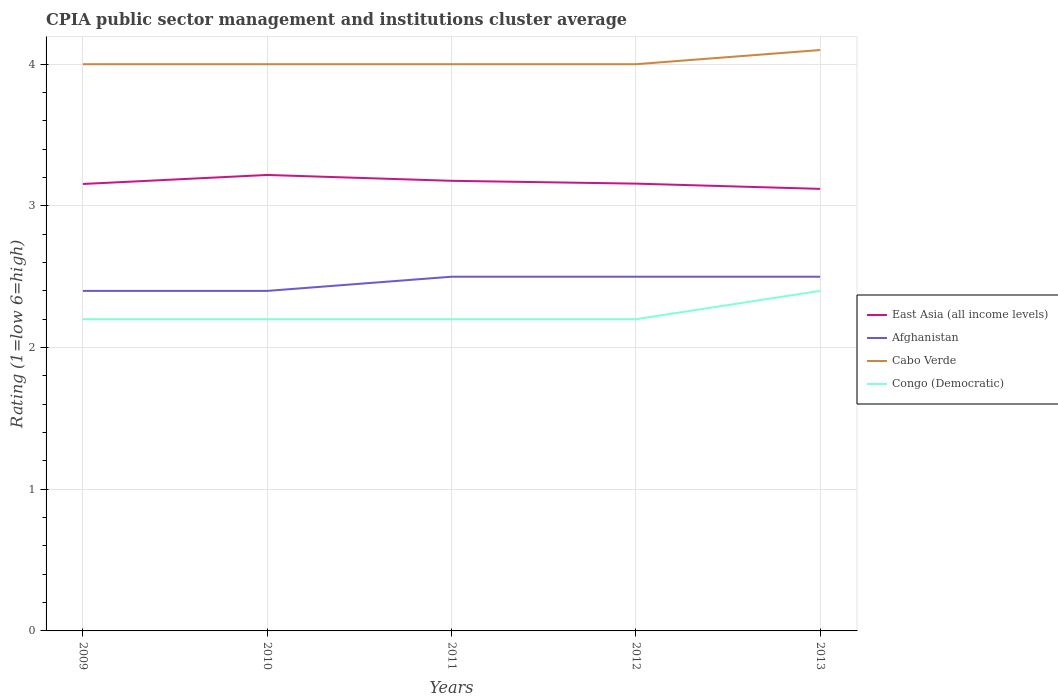Does the line corresponding to East Asia (all income levels) intersect with the line corresponding to Afghanistan?
Provide a short and direct response. No. Is the number of lines equal to the number of legend labels?
Keep it short and to the point. Yes. Across all years, what is the maximum CPIA rating in Afghanistan?
Ensure brevity in your answer.  2.4. In which year was the CPIA rating in East Asia (all income levels) maximum?
Your answer should be compact. 2013. What is the total CPIA rating in East Asia (all income levels) in the graph?
Keep it short and to the point. 0.03. What is the difference between the highest and the second highest CPIA rating in Afghanistan?
Keep it short and to the point. 0.1. Is the CPIA rating in Congo (Democratic) strictly greater than the CPIA rating in Cabo Verde over the years?
Give a very brief answer. Yes. How many years are there in the graph?
Make the answer very short. 5. What is the difference between two consecutive major ticks on the Y-axis?
Your answer should be very brief. 1. Are the values on the major ticks of Y-axis written in scientific E-notation?
Your response must be concise. No. Does the graph contain any zero values?
Your answer should be very brief. No. Does the graph contain grids?
Offer a very short reply. Yes. Where does the legend appear in the graph?
Give a very brief answer. Center right. How many legend labels are there?
Your answer should be compact. 4. How are the legend labels stacked?
Provide a succinct answer. Vertical. What is the title of the graph?
Offer a very short reply. CPIA public sector management and institutions cluster average. Does "High income: OECD" appear as one of the legend labels in the graph?
Make the answer very short. No. What is the Rating (1=low 6=high) in East Asia (all income levels) in 2009?
Your response must be concise. 3.15. What is the Rating (1=low 6=high) in Cabo Verde in 2009?
Your response must be concise. 4. What is the Rating (1=low 6=high) of East Asia (all income levels) in 2010?
Provide a succinct answer. 3.22. What is the Rating (1=low 6=high) of Afghanistan in 2010?
Make the answer very short. 2.4. What is the Rating (1=low 6=high) in East Asia (all income levels) in 2011?
Keep it short and to the point. 3.18. What is the Rating (1=low 6=high) in Cabo Verde in 2011?
Your response must be concise. 4. What is the Rating (1=low 6=high) in East Asia (all income levels) in 2012?
Provide a succinct answer. 3.16. What is the Rating (1=low 6=high) of Cabo Verde in 2012?
Offer a terse response. 4. What is the Rating (1=low 6=high) of East Asia (all income levels) in 2013?
Your response must be concise. 3.12. What is the Rating (1=low 6=high) in Afghanistan in 2013?
Make the answer very short. 2.5. What is the Rating (1=low 6=high) in Cabo Verde in 2013?
Make the answer very short. 4.1. Across all years, what is the maximum Rating (1=low 6=high) in East Asia (all income levels)?
Your answer should be very brief. 3.22. Across all years, what is the maximum Rating (1=low 6=high) in Cabo Verde?
Your response must be concise. 4.1. Across all years, what is the maximum Rating (1=low 6=high) of Congo (Democratic)?
Your response must be concise. 2.4. Across all years, what is the minimum Rating (1=low 6=high) of East Asia (all income levels)?
Provide a short and direct response. 3.12. Across all years, what is the minimum Rating (1=low 6=high) in Afghanistan?
Make the answer very short. 2.4. Across all years, what is the minimum Rating (1=low 6=high) of Congo (Democratic)?
Your answer should be very brief. 2.2. What is the total Rating (1=low 6=high) in East Asia (all income levels) in the graph?
Provide a succinct answer. 15.83. What is the total Rating (1=low 6=high) of Afghanistan in the graph?
Keep it short and to the point. 12.3. What is the total Rating (1=low 6=high) of Cabo Verde in the graph?
Give a very brief answer. 20.1. What is the difference between the Rating (1=low 6=high) in East Asia (all income levels) in 2009 and that in 2010?
Provide a short and direct response. -0.06. What is the difference between the Rating (1=low 6=high) of Cabo Verde in 2009 and that in 2010?
Provide a succinct answer. 0. What is the difference between the Rating (1=low 6=high) of East Asia (all income levels) in 2009 and that in 2011?
Your answer should be very brief. -0.02. What is the difference between the Rating (1=low 6=high) in Afghanistan in 2009 and that in 2011?
Make the answer very short. -0.1. What is the difference between the Rating (1=low 6=high) in East Asia (all income levels) in 2009 and that in 2012?
Ensure brevity in your answer.  -0. What is the difference between the Rating (1=low 6=high) of Afghanistan in 2009 and that in 2012?
Your answer should be compact. -0.1. What is the difference between the Rating (1=low 6=high) in Congo (Democratic) in 2009 and that in 2012?
Offer a very short reply. 0. What is the difference between the Rating (1=low 6=high) in East Asia (all income levels) in 2009 and that in 2013?
Offer a terse response. 0.03. What is the difference between the Rating (1=low 6=high) of Afghanistan in 2009 and that in 2013?
Make the answer very short. -0.1. What is the difference between the Rating (1=low 6=high) of Cabo Verde in 2009 and that in 2013?
Your answer should be compact. -0.1. What is the difference between the Rating (1=low 6=high) of East Asia (all income levels) in 2010 and that in 2011?
Offer a very short reply. 0.04. What is the difference between the Rating (1=low 6=high) of Afghanistan in 2010 and that in 2011?
Provide a succinct answer. -0.1. What is the difference between the Rating (1=low 6=high) of Cabo Verde in 2010 and that in 2011?
Offer a terse response. 0. What is the difference between the Rating (1=low 6=high) of Congo (Democratic) in 2010 and that in 2011?
Provide a short and direct response. 0. What is the difference between the Rating (1=low 6=high) of East Asia (all income levels) in 2010 and that in 2012?
Keep it short and to the point. 0.06. What is the difference between the Rating (1=low 6=high) in Afghanistan in 2010 and that in 2012?
Offer a terse response. -0.1. What is the difference between the Rating (1=low 6=high) of Congo (Democratic) in 2010 and that in 2012?
Provide a succinct answer. 0. What is the difference between the Rating (1=low 6=high) of East Asia (all income levels) in 2010 and that in 2013?
Offer a terse response. 0.1. What is the difference between the Rating (1=low 6=high) in Afghanistan in 2010 and that in 2013?
Make the answer very short. -0.1. What is the difference between the Rating (1=low 6=high) in Congo (Democratic) in 2010 and that in 2013?
Ensure brevity in your answer.  -0.2. What is the difference between the Rating (1=low 6=high) in East Asia (all income levels) in 2011 and that in 2012?
Your response must be concise. 0.02. What is the difference between the Rating (1=low 6=high) of Afghanistan in 2011 and that in 2012?
Give a very brief answer. 0. What is the difference between the Rating (1=low 6=high) in Cabo Verde in 2011 and that in 2012?
Offer a terse response. 0. What is the difference between the Rating (1=low 6=high) in Congo (Democratic) in 2011 and that in 2012?
Your response must be concise. 0. What is the difference between the Rating (1=low 6=high) in East Asia (all income levels) in 2011 and that in 2013?
Offer a very short reply. 0.06. What is the difference between the Rating (1=low 6=high) in Afghanistan in 2011 and that in 2013?
Offer a terse response. 0. What is the difference between the Rating (1=low 6=high) in Cabo Verde in 2011 and that in 2013?
Provide a short and direct response. -0.1. What is the difference between the Rating (1=low 6=high) in East Asia (all income levels) in 2012 and that in 2013?
Offer a terse response. 0.04. What is the difference between the Rating (1=low 6=high) in Afghanistan in 2012 and that in 2013?
Provide a short and direct response. 0. What is the difference between the Rating (1=low 6=high) in East Asia (all income levels) in 2009 and the Rating (1=low 6=high) in Afghanistan in 2010?
Keep it short and to the point. 0.75. What is the difference between the Rating (1=low 6=high) of East Asia (all income levels) in 2009 and the Rating (1=low 6=high) of Cabo Verde in 2010?
Keep it short and to the point. -0.85. What is the difference between the Rating (1=low 6=high) in East Asia (all income levels) in 2009 and the Rating (1=low 6=high) in Congo (Democratic) in 2010?
Your answer should be compact. 0.95. What is the difference between the Rating (1=low 6=high) in Afghanistan in 2009 and the Rating (1=low 6=high) in Congo (Democratic) in 2010?
Keep it short and to the point. 0.2. What is the difference between the Rating (1=low 6=high) of East Asia (all income levels) in 2009 and the Rating (1=low 6=high) of Afghanistan in 2011?
Your answer should be very brief. 0.65. What is the difference between the Rating (1=low 6=high) of East Asia (all income levels) in 2009 and the Rating (1=low 6=high) of Cabo Verde in 2011?
Offer a terse response. -0.85. What is the difference between the Rating (1=low 6=high) in East Asia (all income levels) in 2009 and the Rating (1=low 6=high) in Congo (Democratic) in 2011?
Ensure brevity in your answer.  0.95. What is the difference between the Rating (1=low 6=high) in Afghanistan in 2009 and the Rating (1=low 6=high) in Cabo Verde in 2011?
Offer a terse response. -1.6. What is the difference between the Rating (1=low 6=high) of Cabo Verde in 2009 and the Rating (1=low 6=high) of Congo (Democratic) in 2011?
Provide a succinct answer. 1.8. What is the difference between the Rating (1=low 6=high) of East Asia (all income levels) in 2009 and the Rating (1=low 6=high) of Afghanistan in 2012?
Offer a terse response. 0.65. What is the difference between the Rating (1=low 6=high) of East Asia (all income levels) in 2009 and the Rating (1=low 6=high) of Cabo Verde in 2012?
Provide a short and direct response. -0.85. What is the difference between the Rating (1=low 6=high) in East Asia (all income levels) in 2009 and the Rating (1=low 6=high) in Congo (Democratic) in 2012?
Your response must be concise. 0.95. What is the difference between the Rating (1=low 6=high) in Afghanistan in 2009 and the Rating (1=low 6=high) in Cabo Verde in 2012?
Your answer should be compact. -1.6. What is the difference between the Rating (1=low 6=high) of Cabo Verde in 2009 and the Rating (1=low 6=high) of Congo (Democratic) in 2012?
Keep it short and to the point. 1.8. What is the difference between the Rating (1=low 6=high) in East Asia (all income levels) in 2009 and the Rating (1=low 6=high) in Afghanistan in 2013?
Your answer should be compact. 0.65. What is the difference between the Rating (1=low 6=high) of East Asia (all income levels) in 2009 and the Rating (1=low 6=high) of Cabo Verde in 2013?
Your response must be concise. -0.95. What is the difference between the Rating (1=low 6=high) of East Asia (all income levels) in 2009 and the Rating (1=low 6=high) of Congo (Democratic) in 2013?
Provide a succinct answer. 0.75. What is the difference between the Rating (1=low 6=high) in Afghanistan in 2009 and the Rating (1=low 6=high) in Cabo Verde in 2013?
Offer a very short reply. -1.7. What is the difference between the Rating (1=low 6=high) in Cabo Verde in 2009 and the Rating (1=low 6=high) in Congo (Democratic) in 2013?
Make the answer very short. 1.6. What is the difference between the Rating (1=low 6=high) in East Asia (all income levels) in 2010 and the Rating (1=low 6=high) in Afghanistan in 2011?
Your answer should be very brief. 0.72. What is the difference between the Rating (1=low 6=high) in East Asia (all income levels) in 2010 and the Rating (1=low 6=high) in Cabo Verde in 2011?
Your answer should be compact. -0.78. What is the difference between the Rating (1=low 6=high) in East Asia (all income levels) in 2010 and the Rating (1=low 6=high) in Congo (Democratic) in 2011?
Offer a terse response. 1.02. What is the difference between the Rating (1=low 6=high) in Afghanistan in 2010 and the Rating (1=low 6=high) in Cabo Verde in 2011?
Your answer should be compact. -1.6. What is the difference between the Rating (1=low 6=high) in East Asia (all income levels) in 2010 and the Rating (1=low 6=high) in Afghanistan in 2012?
Make the answer very short. 0.72. What is the difference between the Rating (1=low 6=high) in East Asia (all income levels) in 2010 and the Rating (1=low 6=high) in Cabo Verde in 2012?
Offer a terse response. -0.78. What is the difference between the Rating (1=low 6=high) of East Asia (all income levels) in 2010 and the Rating (1=low 6=high) of Congo (Democratic) in 2012?
Provide a succinct answer. 1.02. What is the difference between the Rating (1=low 6=high) of Afghanistan in 2010 and the Rating (1=low 6=high) of Cabo Verde in 2012?
Your answer should be very brief. -1.6. What is the difference between the Rating (1=low 6=high) of East Asia (all income levels) in 2010 and the Rating (1=low 6=high) of Afghanistan in 2013?
Offer a terse response. 0.72. What is the difference between the Rating (1=low 6=high) in East Asia (all income levels) in 2010 and the Rating (1=low 6=high) in Cabo Verde in 2013?
Ensure brevity in your answer.  -0.88. What is the difference between the Rating (1=low 6=high) of East Asia (all income levels) in 2010 and the Rating (1=low 6=high) of Congo (Democratic) in 2013?
Provide a short and direct response. 0.82. What is the difference between the Rating (1=low 6=high) of Cabo Verde in 2010 and the Rating (1=low 6=high) of Congo (Democratic) in 2013?
Provide a short and direct response. 1.6. What is the difference between the Rating (1=low 6=high) of East Asia (all income levels) in 2011 and the Rating (1=low 6=high) of Afghanistan in 2012?
Give a very brief answer. 0.68. What is the difference between the Rating (1=low 6=high) of East Asia (all income levels) in 2011 and the Rating (1=low 6=high) of Cabo Verde in 2012?
Provide a short and direct response. -0.82. What is the difference between the Rating (1=low 6=high) of East Asia (all income levels) in 2011 and the Rating (1=low 6=high) of Congo (Democratic) in 2012?
Offer a terse response. 0.98. What is the difference between the Rating (1=low 6=high) in Afghanistan in 2011 and the Rating (1=low 6=high) in Cabo Verde in 2012?
Provide a short and direct response. -1.5. What is the difference between the Rating (1=low 6=high) in Cabo Verde in 2011 and the Rating (1=low 6=high) in Congo (Democratic) in 2012?
Offer a terse response. 1.8. What is the difference between the Rating (1=low 6=high) in East Asia (all income levels) in 2011 and the Rating (1=low 6=high) in Afghanistan in 2013?
Your answer should be very brief. 0.68. What is the difference between the Rating (1=low 6=high) of East Asia (all income levels) in 2011 and the Rating (1=low 6=high) of Cabo Verde in 2013?
Make the answer very short. -0.92. What is the difference between the Rating (1=low 6=high) of East Asia (all income levels) in 2011 and the Rating (1=low 6=high) of Congo (Democratic) in 2013?
Give a very brief answer. 0.78. What is the difference between the Rating (1=low 6=high) of Afghanistan in 2011 and the Rating (1=low 6=high) of Congo (Democratic) in 2013?
Your answer should be compact. 0.1. What is the difference between the Rating (1=low 6=high) of Cabo Verde in 2011 and the Rating (1=low 6=high) of Congo (Democratic) in 2013?
Offer a very short reply. 1.6. What is the difference between the Rating (1=low 6=high) of East Asia (all income levels) in 2012 and the Rating (1=low 6=high) of Afghanistan in 2013?
Your answer should be very brief. 0.66. What is the difference between the Rating (1=low 6=high) of East Asia (all income levels) in 2012 and the Rating (1=low 6=high) of Cabo Verde in 2013?
Your answer should be very brief. -0.94. What is the difference between the Rating (1=low 6=high) in East Asia (all income levels) in 2012 and the Rating (1=low 6=high) in Congo (Democratic) in 2013?
Provide a succinct answer. 0.76. What is the difference between the Rating (1=low 6=high) in Afghanistan in 2012 and the Rating (1=low 6=high) in Cabo Verde in 2013?
Your response must be concise. -1.6. What is the average Rating (1=low 6=high) in East Asia (all income levels) per year?
Give a very brief answer. 3.17. What is the average Rating (1=low 6=high) in Afghanistan per year?
Your answer should be very brief. 2.46. What is the average Rating (1=low 6=high) of Cabo Verde per year?
Make the answer very short. 4.02. What is the average Rating (1=low 6=high) in Congo (Democratic) per year?
Offer a terse response. 2.24. In the year 2009, what is the difference between the Rating (1=low 6=high) in East Asia (all income levels) and Rating (1=low 6=high) in Afghanistan?
Your answer should be compact. 0.75. In the year 2009, what is the difference between the Rating (1=low 6=high) in East Asia (all income levels) and Rating (1=low 6=high) in Cabo Verde?
Your answer should be compact. -0.85. In the year 2009, what is the difference between the Rating (1=low 6=high) of East Asia (all income levels) and Rating (1=low 6=high) of Congo (Democratic)?
Offer a terse response. 0.95. In the year 2010, what is the difference between the Rating (1=low 6=high) of East Asia (all income levels) and Rating (1=low 6=high) of Afghanistan?
Ensure brevity in your answer.  0.82. In the year 2010, what is the difference between the Rating (1=low 6=high) in East Asia (all income levels) and Rating (1=low 6=high) in Cabo Verde?
Provide a short and direct response. -0.78. In the year 2010, what is the difference between the Rating (1=low 6=high) in East Asia (all income levels) and Rating (1=low 6=high) in Congo (Democratic)?
Make the answer very short. 1.02. In the year 2010, what is the difference between the Rating (1=low 6=high) in Afghanistan and Rating (1=low 6=high) in Cabo Verde?
Provide a succinct answer. -1.6. In the year 2010, what is the difference between the Rating (1=low 6=high) of Afghanistan and Rating (1=low 6=high) of Congo (Democratic)?
Make the answer very short. 0.2. In the year 2011, what is the difference between the Rating (1=low 6=high) of East Asia (all income levels) and Rating (1=low 6=high) of Afghanistan?
Provide a succinct answer. 0.68. In the year 2011, what is the difference between the Rating (1=low 6=high) in East Asia (all income levels) and Rating (1=low 6=high) in Cabo Verde?
Provide a succinct answer. -0.82. In the year 2011, what is the difference between the Rating (1=low 6=high) of East Asia (all income levels) and Rating (1=low 6=high) of Congo (Democratic)?
Your answer should be very brief. 0.98. In the year 2011, what is the difference between the Rating (1=low 6=high) of Afghanistan and Rating (1=low 6=high) of Cabo Verde?
Give a very brief answer. -1.5. In the year 2011, what is the difference between the Rating (1=low 6=high) of Afghanistan and Rating (1=low 6=high) of Congo (Democratic)?
Provide a short and direct response. 0.3. In the year 2012, what is the difference between the Rating (1=low 6=high) of East Asia (all income levels) and Rating (1=low 6=high) of Afghanistan?
Offer a very short reply. 0.66. In the year 2012, what is the difference between the Rating (1=low 6=high) of East Asia (all income levels) and Rating (1=low 6=high) of Cabo Verde?
Your answer should be compact. -0.84. In the year 2012, what is the difference between the Rating (1=low 6=high) of East Asia (all income levels) and Rating (1=low 6=high) of Congo (Democratic)?
Your response must be concise. 0.96. In the year 2013, what is the difference between the Rating (1=low 6=high) in East Asia (all income levels) and Rating (1=low 6=high) in Afghanistan?
Give a very brief answer. 0.62. In the year 2013, what is the difference between the Rating (1=low 6=high) of East Asia (all income levels) and Rating (1=low 6=high) of Cabo Verde?
Keep it short and to the point. -0.98. In the year 2013, what is the difference between the Rating (1=low 6=high) of East Asia (all income levels) and Rating (1=low 6=high) of Congo (Democratic)?
Make the answer very short. 0.72. In the year 2013, what is the difference between the Rating (1=low 6=high) in Afghanistan and Rating (1=low 6=high) in Congo (Democratic)?
Give a very brief answer. 0.1. What is the ratio of the Rating (1=low 6=high) in East Asia (all income levels) in 2009 to that in 2010?
Offer a terse response. 0.98. What is the ratio of the Rating (1=low 6=high) in Cabo Verde in 2009 to that in 2010?
Your answer should be compact. 1. What is the ratio of the Rating (1=low 6=high) of Congo (Democratic) in 2009 to that in 2010?
Offer a very short reply. 1. What is the ratio of the Rating (1=low 6=high) of Afghanistan in 2009 to that in 2011?
Your response must be concise. 0.96. What is the ratio of the Rating (1=low 6=high) of Congo (Democratic) in 2009 to that in 2011?
Your answer should be very brief. 1. What is the ratio of the Rating (1=low 6=high) of East Asia (all income levels) in 2009 to that in 2012?
Make the answer very short. 1. What is the ratio of the Rating (1=low 6=high) of Afghanistan in 2009 to that in 2012?
Keep it short and to the point. 0.96. What is the ratio of the Rating (1=low 6=high) of Cabo Verde in 2009 to that in 2012?
Offer a very short reply. 1. What is the ratio of the Rating (1=low 6=high) in Congo (Democratic) in 2009 to that in 2012?
Offer a very short reply. 1. What is the ratio of the Rating (1=low 6=high) of East Asia (all income levels) in 2009 to that in 2013?
Give a very brief answer. 1.01. What is the ratio of the Rating (1=low 6=high) in Cabo Verde in 2009 to that in 2013?
Provide a short and direct response. 0.98. What is the ratio of the Rating (1=low 6=high) in Afghanistan in 2010 to that in 2011?
Give a very brief answer. 0.96. What is the ratio of the Rating (1=low 6=high) of East Asia (all income levels) in 2010 to that in 2012?
Make the answer very short. 1.02. What is the ratio of the Rating (1=low 6=high) of Afghanistan in 2010 to that in 2012?
Provide a short and direct response. 0.96. What is the ratio of the Rating (1=low 6=high) in Cabo Verde in 2010 to that in 2012?
Provide a succinct answer. 1. What is the ratio of the Rating (1=low 6=high) of East Asia (all income levels) in 2010 to that in 2013?
Give a very brief answer. 1.03. What is the ratio of the Rating (1=low 6=high) in Cabo Verde in 2010 to that in 2013?
Ensure brevity in your answer.  0.98. What is the ratio of the Rating (1=low 6=high) of Congo (Democratic) in 2010 to that in 2013?
Ensure brevity in your answer.  0.92. What is the ratio of the Rating (1=low 6=high) of East Asia (all income levels) in 2011 to that in 2012?
Provide a succinct answer. 1.01. What is the ratio of the Rating (1=low 6=high) of Afghanistan in 2011 to that in 2012?
Your answer should be compact. 1. What is the ratio of the Rating (1=low 6=high) in East Asia (all income levels) in 2011 to that in 2013?
Provide a short and direct response. 1.02. What is the ratio of the Rating (1=low 6=high) in Afghanistan in 2011 to that in 2013?
Your response must be concise. 1. What is the ratio of the Rating (1=low 6=high) of Cabo Verde in 2011 to that in 2013?
Offer a very short reply. 0.98. What is the ratio of the Rating (1=low 6=high) of East Asia (all income levels) in 2012 to that in 2013?
Your response must be concise. 1.01. What is the ratio of the Rating (1=low 6=high) of Afghanistan in 2012 to that in 2013?
Ensure brevity in your answer.  1. What is the ratio of the Rating (1=low 6=high) in Cabo Verde in 2012 to that in 2013?
Keep it short and to the point. 0.98. What is the ratio of the Rating (1=low 6=high) in Congo (Democratic) in 2012 to that in 2013?
Your answer should be compact. 0.92. What is the difference between the highest and the second highest Rating (1=low 6=high) in East Asia (all income levels)?
Your answer should be very brief. 0.04. What is the difference between the highest and the second highest Rating (1=low 6=high) in Afghanistan?
Give a very brief answer. 0. What is the difference between the highest and the second highest Rating (1=low 6=high) of Cabo Verde?
Ensure brevity in your answer.  0.1. What is the difference between the highest and the second highest Rating (1=low 6=high) in Congo (Democratic)?
Your answer should be compact. 0.2. What is the difference between the highest and the lowest Rating (1=low 6=high) in East Asia (all income levels)?
Your response must be concise. 0.1. What is the difference between the highest and the lowest Rating (1=low 6=high) of Afghanistan?
Offer a very short reply. 0.1. 